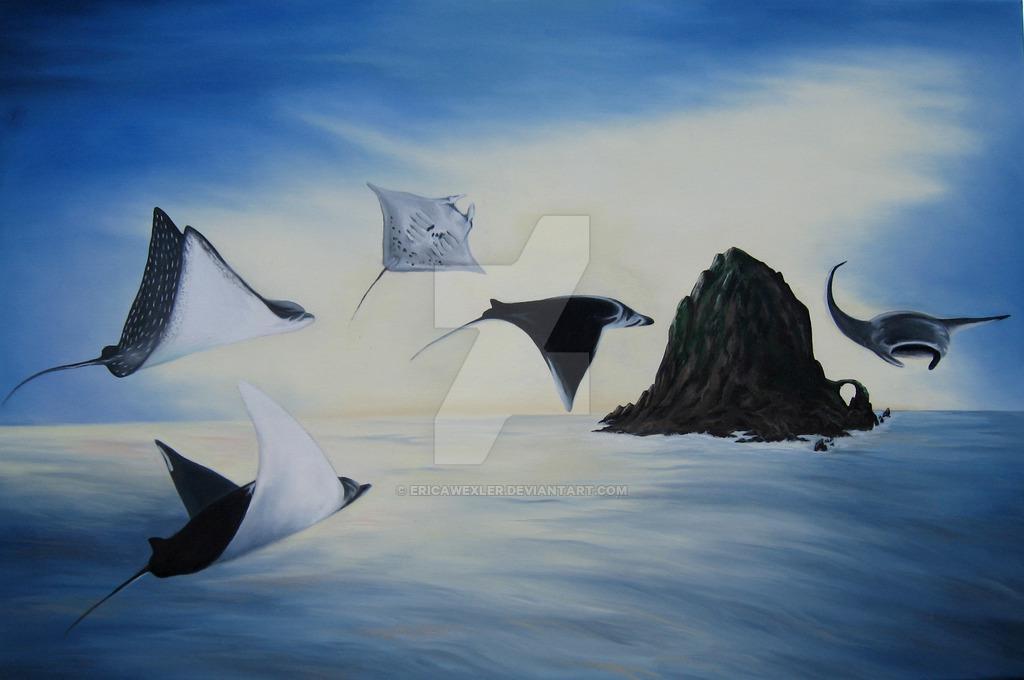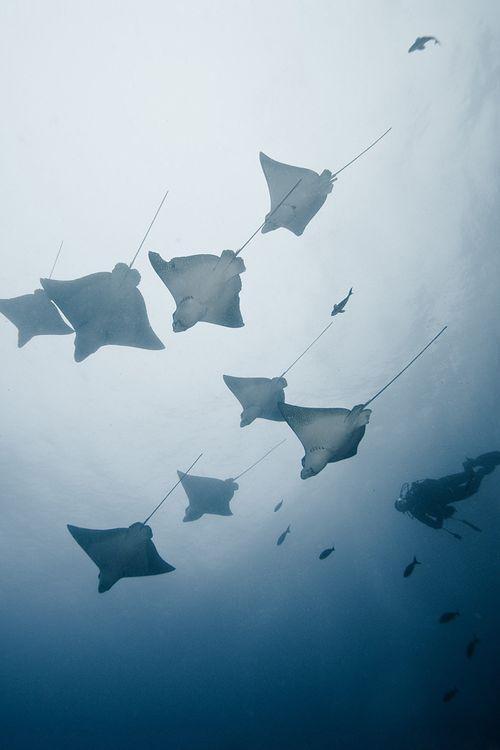The first image is the image on the left, the second image is the image on the right. For the images shown, is this caption "There is exactly one stingray in the image on the left." true? Answer yes or no. No. The first image is the image on the left, the second image is the image on the right. For the images displayed, is the sentence "One image contains dozens of stingrays swimming close together." factually correct? Answer yes or no. No. 